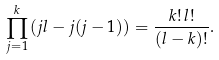<formula> <loc_0><loc_0><loc_500><loc_500>\prod _ { j = 1 } ^ { k } \left ( j l - j ( j - 1 ) \right ) = \frac { k ! \, l ! } { ( l - k ) ! } .</formula> 